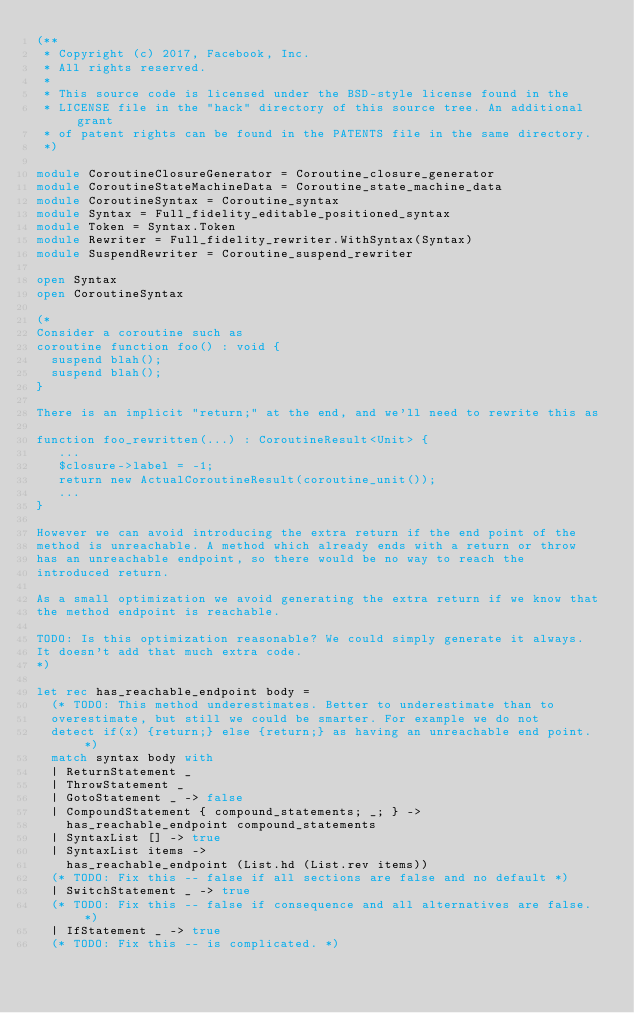Convert code to text. <code><loc_0><loc_0><loc_500><loc_500><_OCaml_>(**
 * Copyright (c) 2017, Facebook, Inc.
 * All rights reserved.
 *
 * This source code is licensed under the BSD-style license found in the
 * LICENSE file in the "hack" directory of this source tree. An additional grant
 * of patent rights can be found in the PATENTS file in the same directory.
 *)

module CoroutineClosureGenerator = Coroutine_closure_generator
module CoroutineStateMachineData = Coroutine_state_machine_data
module CoroutineSyntax = Coroutine_syntax
module Syntax = Full_fidelity_editable_positioned_syntax
module Token = Syntax.Token
module Rewriter = Full_fidelity_rewriter.WithSyntax(Syntax)
module SuspendRewriter = Coroutine_suspend_rewriter

open Syntax
open CoroutineSyntax

(*
Consider a coroutine such as
coroutine function foo() : void {
  suspend blah();
  suspend blah();
}

There is an implicit "return;" at the end, and we'll need to rewrite this as

function foo_rewritten(...) : CoroutineResult<Unit> {
   ...
   $closure->label = -1;
   return new ActualCoroutineResult(coroutine_unit());
   ...
}

However we can avoid introducing the extra return if the end point of the
method is unreachable. A method which already ends with a return or throw
has an unreachable endpoint, so there would be no way to reach the
introduced return.

As a small optimization we avoid generating the extra return if we know that
the method endpoint is reachable.

TODO: Is this optimization reasonable? We could simply generate it always.
It doesn't add that much extra code.
*)

let rec has_reachable_endpoint body =
  (* TODO: This method underestimates. Better to underestimate than to
  overestimate, but still we could be smarter. For example we do not
  detect if(x) {return;} else {return;} as having an unreachable end point. *)
  match syntax body with
  | ReturnStatement _
  | ThrowStatement _
  | GotoStatement _ -> false
  | CompoundStatement { compound_statements; _; } ->
    has_reachable_endpoint compound_statements
  | SyntaxList [] -> true
  | SyntaxList items ->
    has_reachable_endpoint (List.hd (List.rev items))
  (* TODO: Fix this -- false if all sections are false and no default *)
  | SwitchStatement _ -> true
  (* TODO: Fix this -- false if consequence and all alternatives are false. *)
  | IfStatement _ -> true
  (* TODO: Fix this -- is complicated. *)</code> 